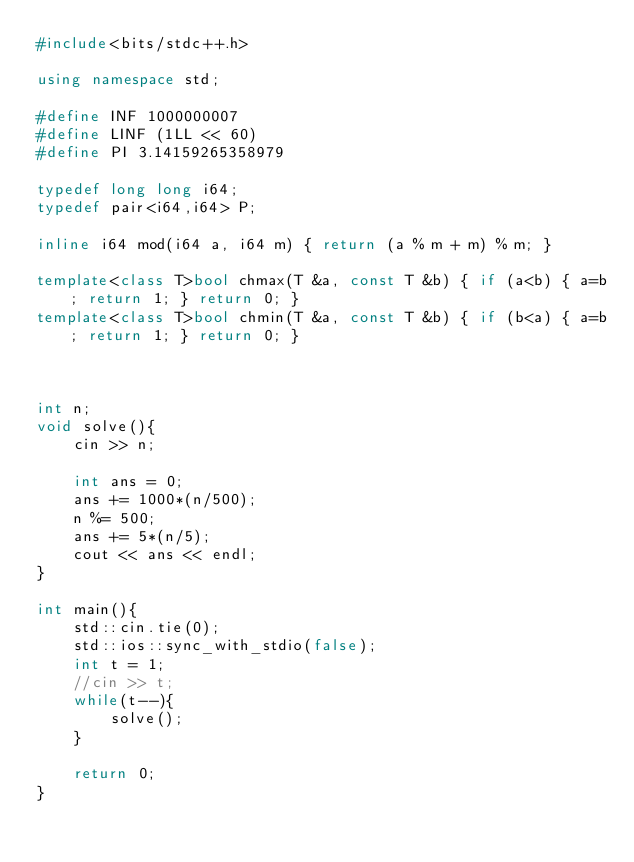<code> <loc_0><loc_0><loc_500><loc_500><_C++_>#include<bits/stdc++.h>

using namespace std;

#define INF 1000000007
#define LINF (1LL << 60)
#define PI 3.14159265358979

typedef long long i64;
typedef pair<i64,i64> P;

inline i64 mod(i64 a, i64 m) { return (a % m + m) % m; }

template<class T>bool chmax(T &a, const T &b) { if (a<b) { a=b; return 1; } return 0; }
template<class T>bool chmin(T &a, const T &b) { if (b<a) { a=b; return 1; } return 0; }



int n;
void solve(){
	cin >> n;
	
	int ans = 0;
	ans += 1000*(n/500);
	n %= 500;
	ans += 5*(n/5);
	cout << ans << endl;
}

int main(){
	std::cin.tie(0);
	std::ios::sync_with_stdio(false);
	int t = 1;
	//cin >> t;
	while(t--){
		solve();
	}
	
	return 0;
}
</code> 